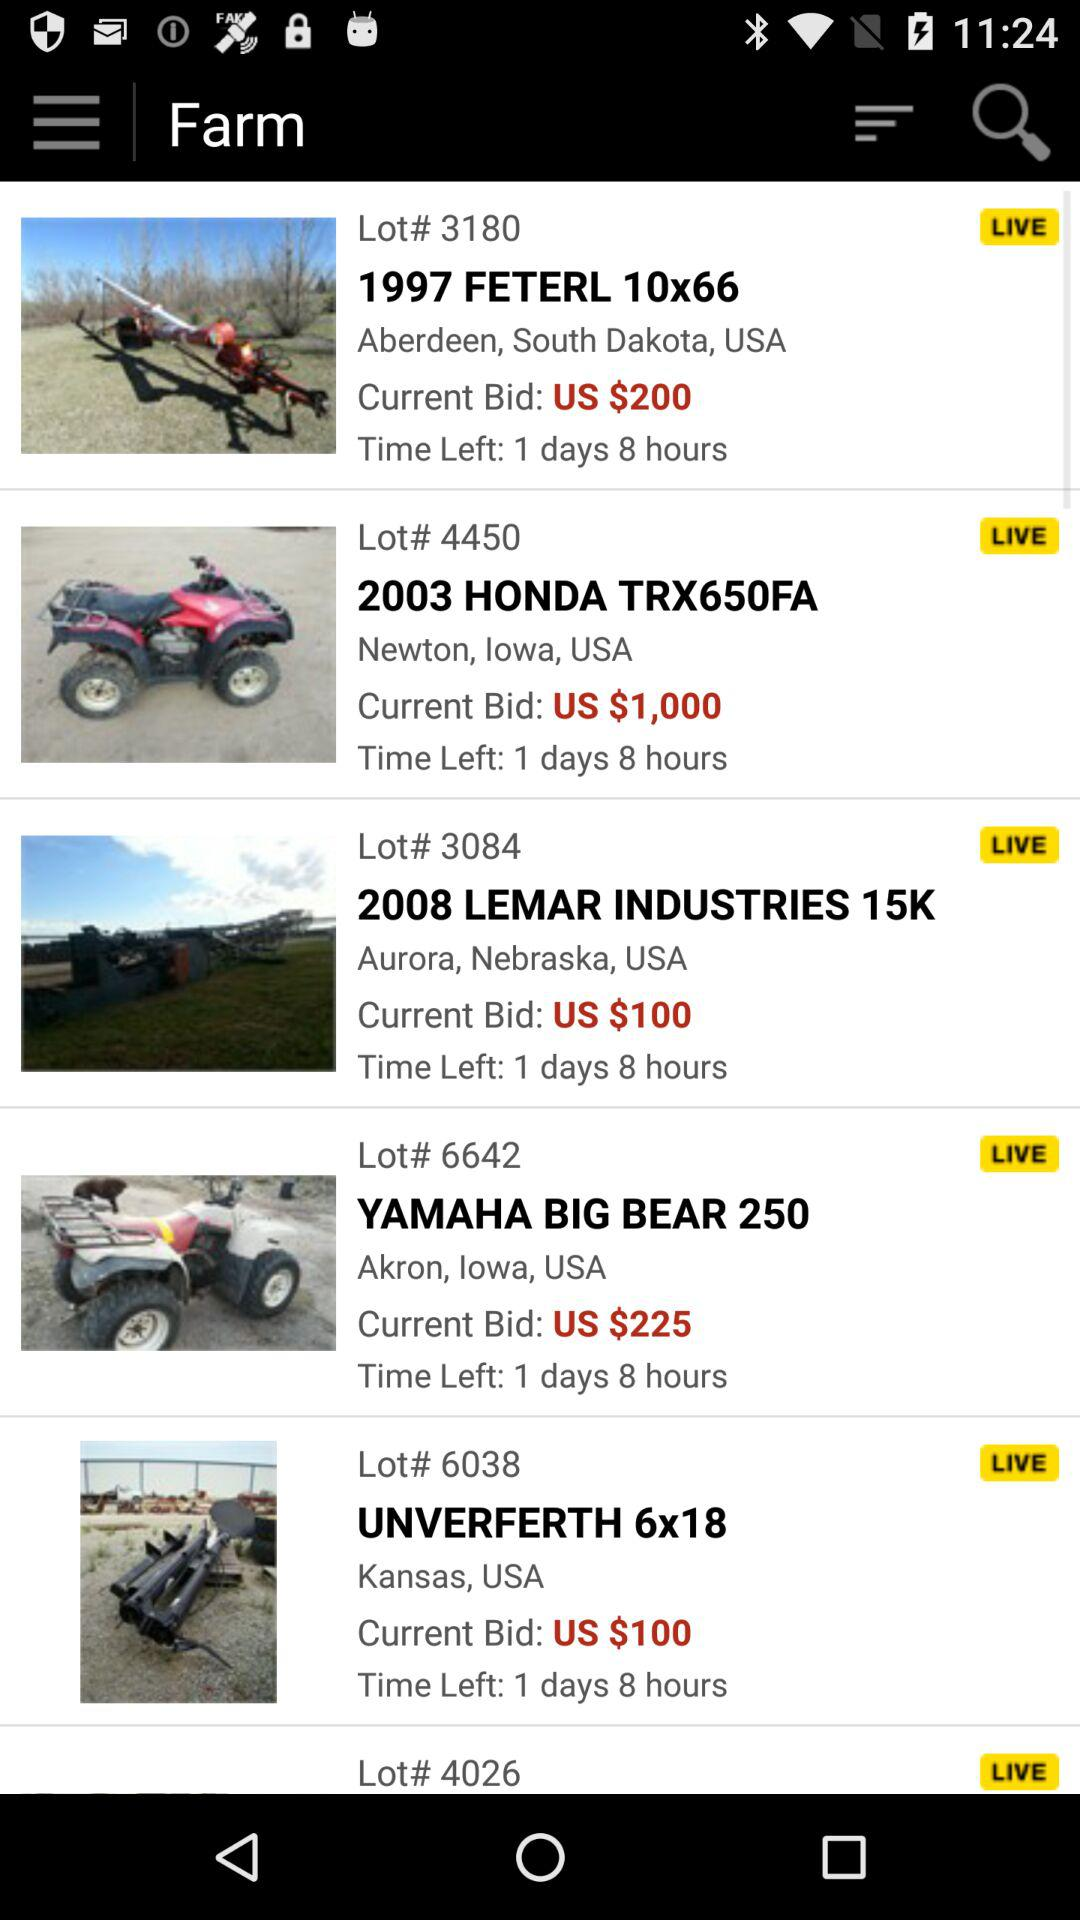What is the current bid price for "UNVERFERTH 6x18"? The current bid price is $100. 